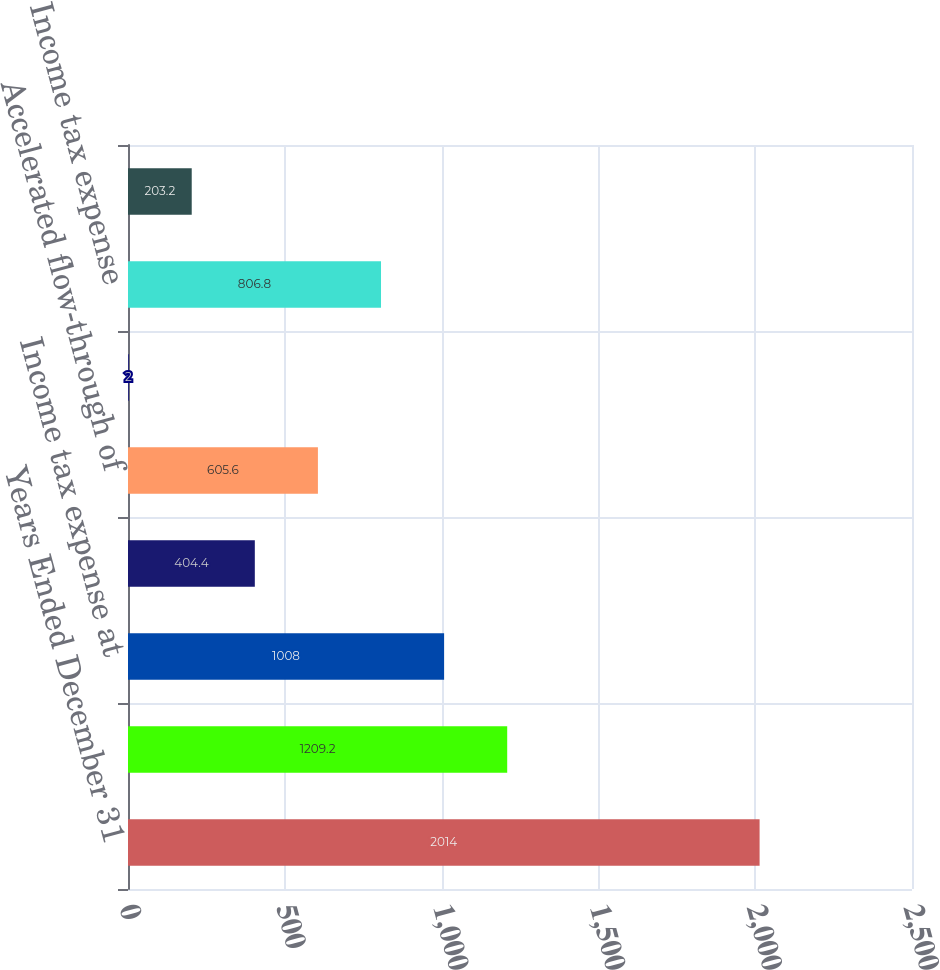Convert chart to OTSL. <chart><loc_0><loc_0><loc_500><loc_500><bar_chart><fcel>Years Ended December 31<fcel>Income from continuing<fcel>Income tax expense at<fcel>State and local income taxes<fcel>Accelerated flow-through of<fcel>Other net<fcel>Income tax expense<fcel>Effective tax rate<nl><fcel>2014<fcel>1209.2<fcel>1008<fcel>404.4<fcel>605.6<fcel>2<fcel>806.8<fcel>203.2<nl></chart> 